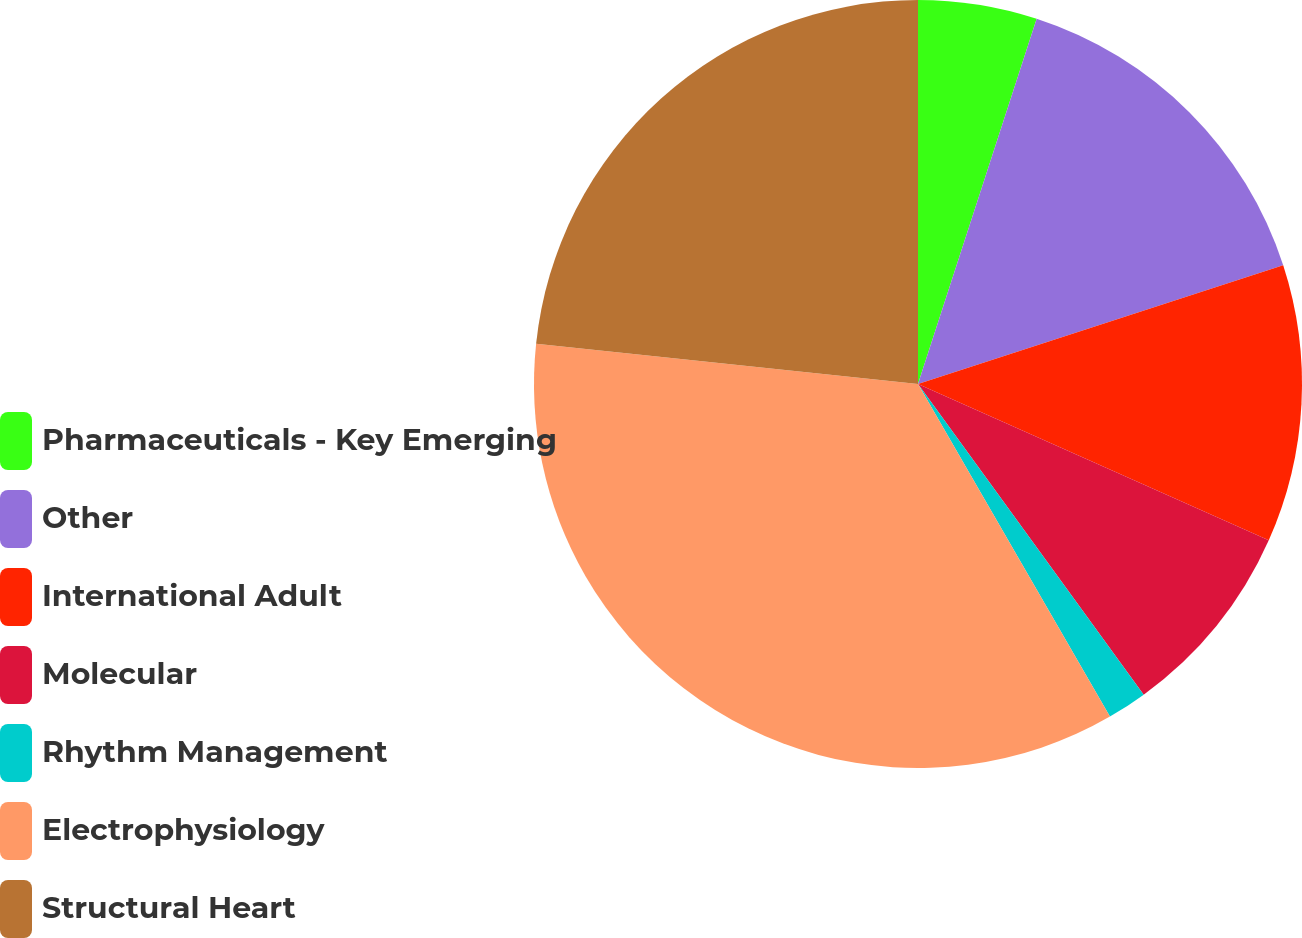Convert chart. <chart><loc_0><loc_0><loc_500><loc_500><pie_chart><fcel>Pharmaceuticals - Key Emerging<fcel>Other<fcel>International Adult<fcel>Molecular<fcel>Rhythm Management<fcel>Electrophysiology<fcel>Structural Heart<nl><fcel>5.0%<fcel>15.0%<fcel>11.67%<fcel>8.33%<fcel>1.67%<fcel>35.0%<fcel>23.33%<nl></chart> 